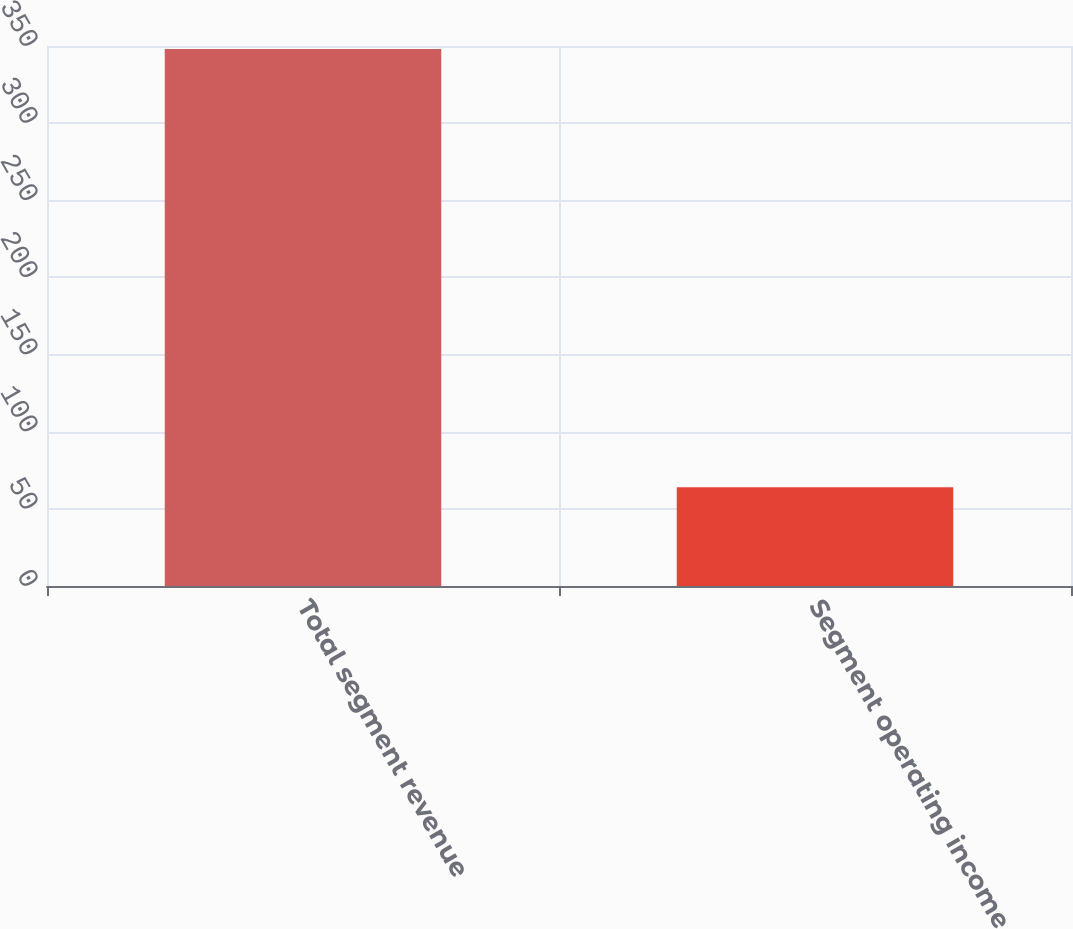Convert chart to OTSL. <chart><loc_0><loc_0><loc_500><loc_500><bar_chart><fcel>Total segment revenue<fcel>Segment operating income<nl><fcel>348<fcel>64<nl></chart> 